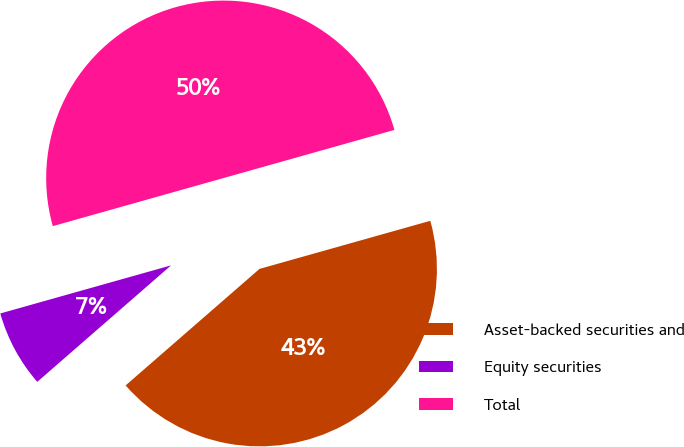Convert chart. <chart><loc_0><loc_0><loc_500><loc_500><pie_chart><fcel>Asset-backed securities and<fcel>Equity securities<fcel>Total<nl><fcel>42.97%<fcel>7.03%<fcel>50.0%<nl></chart> 